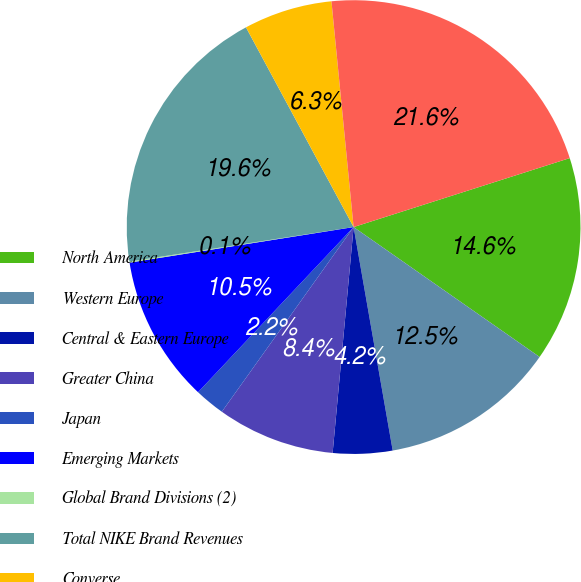Convert chart to OTSL. <chart><loc_0><loc_0><loc_500><loc_500><pie_chart><fcel>North America<fcel>Western Europe<fcel>Central & Eastern Europe<fcel>Greater China<fcel>Japan<fcel>Emerging Markets<fcel>Global Brand Divisions (2)<fcel>Total NIKE Brand Revenues<fcel>Converse<fcel>TOTAL NIKE INC REVENUES<nl><fcel>14.62%<fcel>12.54%<fcel>4.23%<fcel>8.39%<fcel>2.16%<fcel>10.47%<fcel>0.08%<fcel>19.56%<fcel>6.31%<fcel>21.64%<nl></chart> 